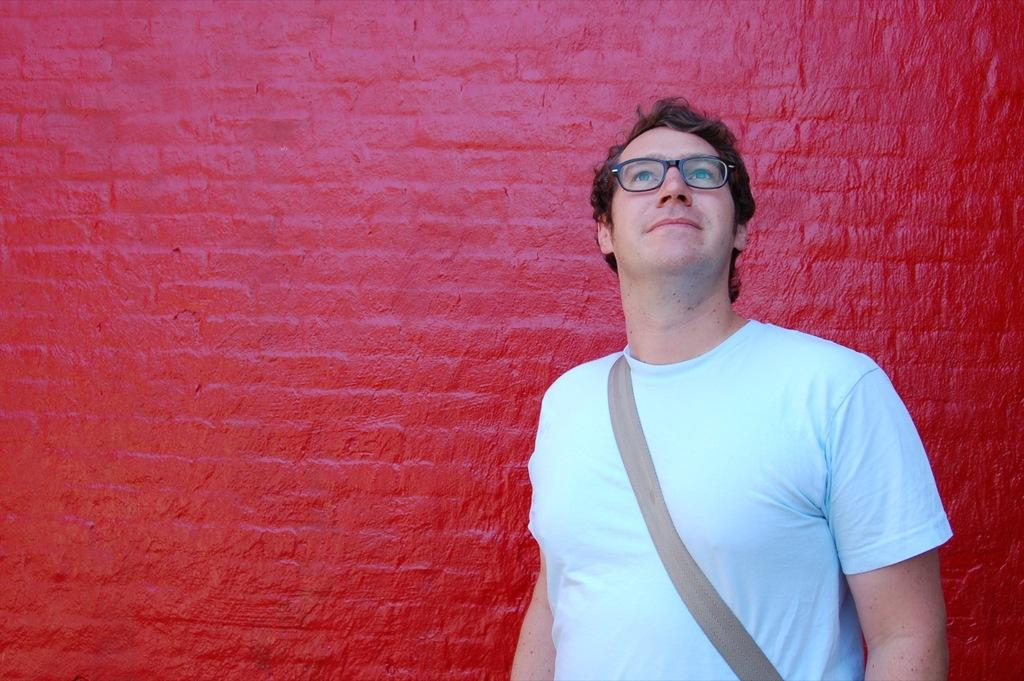Who is the main subject in the image? There is a man in the middle of the image. What is the man wearing? The man is wearing a bag and spectacles. What can be seen in the background of the image? There is a wall in the background of the image. What is the color of the wall? The wall has red color paint on it. What type of street is visible in the image? There is no street visible in the image; it only shows a man and a wall in the background. How many parcels is the man holding in the image? The man is not holding any parcels in the image. 